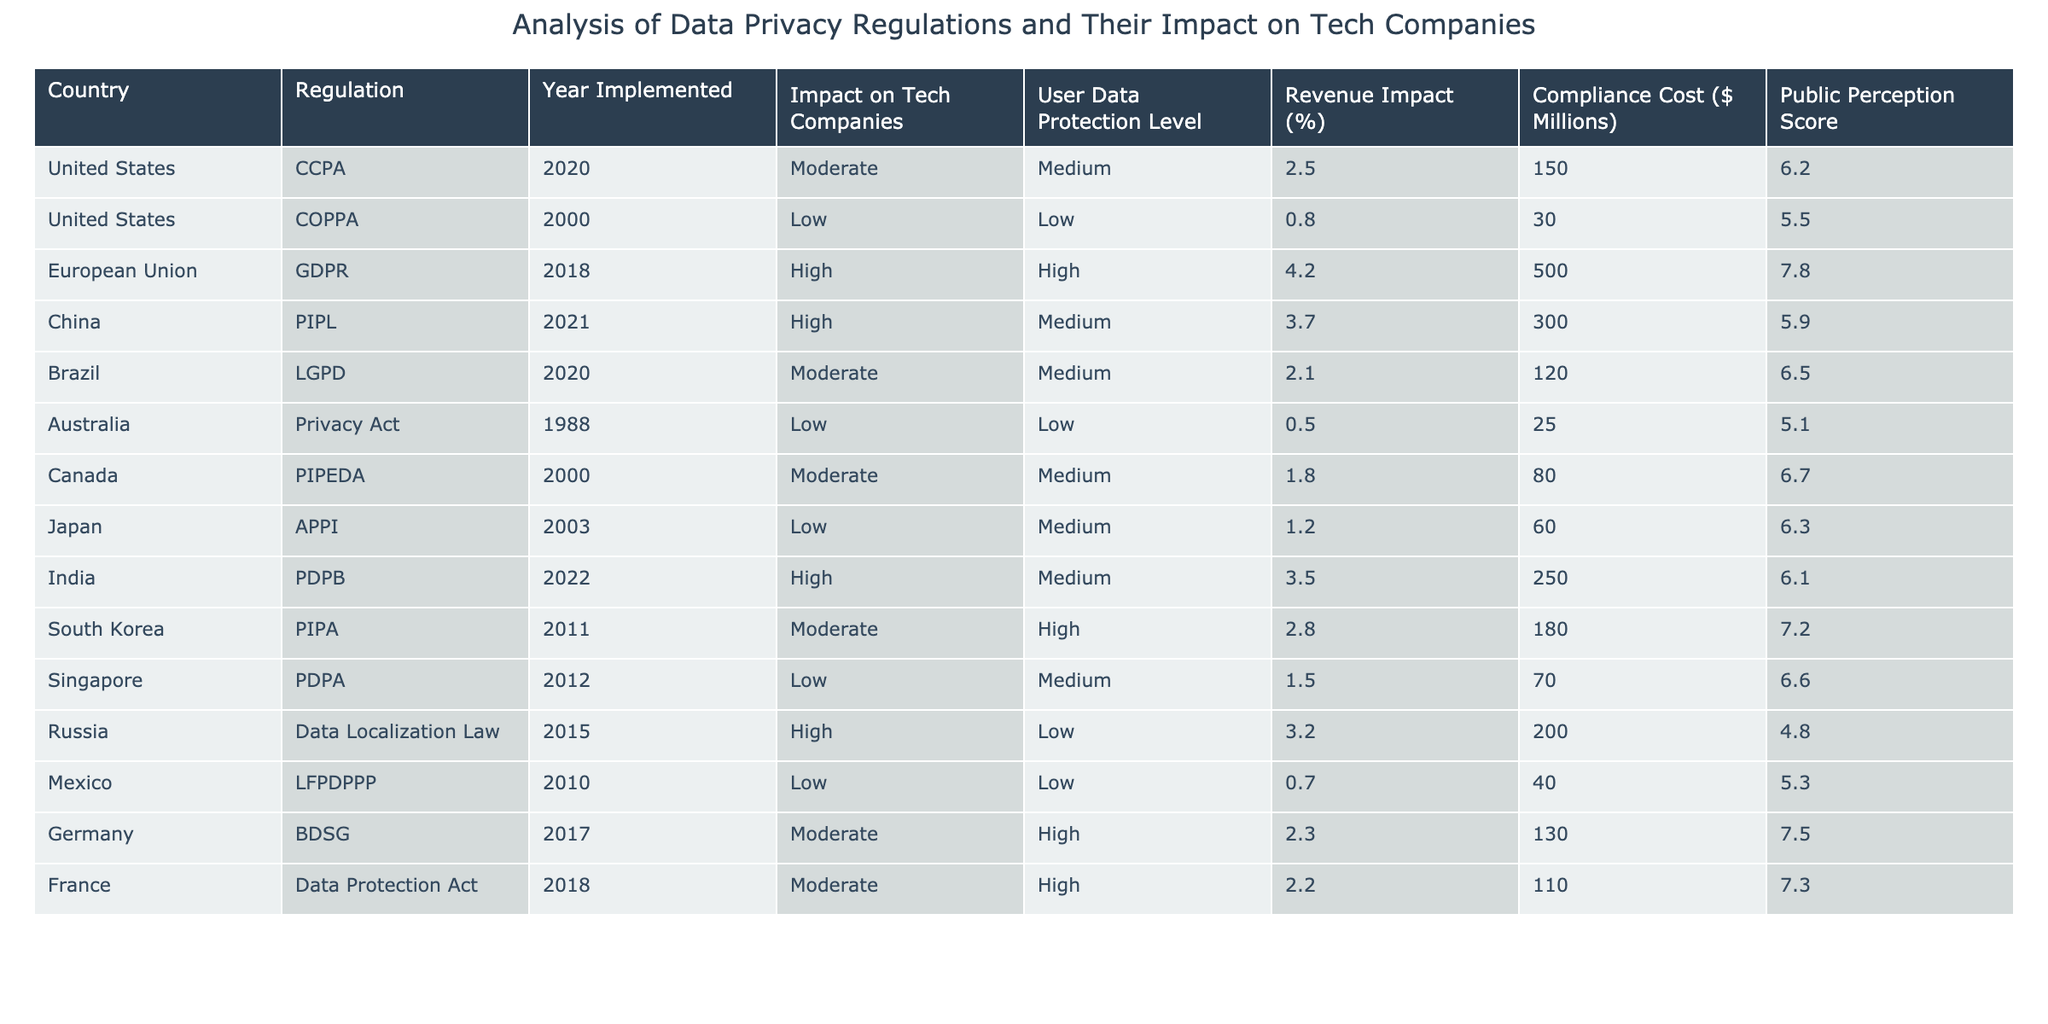What is the impact level of the GDPR on tech companies? The table lists the GDPR as having a "High" impact on tech companies.
Answer: High Which country has the highest revenue impact percentage? The table shows that the European Union (GDPR) has the highest revenue impact percentage at 4.2%.
Answer: 4.2% What is the compliance cost for the CCPA in the United States? According to the table, the compliance cost for CCPA is $150 million.
Answer: $150 million How many countries have a high user data protection level? From the table, the countries with a high user data protection level are the European Union (GDPR), China (PIPL), South Korea (PIPA), Germany (BDSG), and France (Data Protection Act), totaling five countries.
Answer: 5 What is the median compliance cost among the listed countries? First, list the compliance costs: [150, 30, 500, 300, 120, 25, 80, 60, 250, 180, 70, 200, 40, 130, 110]. The sorted costs are: [25, 30, 40, 60, 70, 80, 120, 130, 150, 180, 200, 250, 300, 500]. With 15 data points, the median is the 8th value, which is $130 million.
Answer: $130 million Which regulation has a low impact on tech companies? The table indicates COPPA, the Privacy Act, and LFPDPPP as having low impacts on tech companies.
Answer: COPPA, Privacy Act, LFPDPPP Is it true that all countries with high compliance costs also have high public perception scores? Analyzing the data, we observe that the countries with high compliance costs (GDPR, PIPL, PDPB, PIPA, Data Localization Law) do not all have high public perception scores, as Russia has a low score. Thus, the statement is false.
Answer: False What is the average user data protection level for countries with moderate impacts on tech companies? The countries with moderate impacts are the United States (CCPA, LGPD), Brazil, and Canada. Their user data protection levels are Medium, Medium, Medium, and Medium. Since they are all the same, the average remains Medium.
Answer: Medium Which country implemented data protection regulations earliest, and what was the year? Based on the table, Australia’s Privacy Act was implemented in 1988, making it the earliest data protection regulation listed.
Answer: Australia, 1988 Is there a correlation between public perception score and user data protection level? By analyzing the public perception scores and user data protection levels, we see varying scores across different protection levels, making it difficult to establish a clear correlation. Therefore, the answer is no.
Answer: No What is the total compliance cost for the top three countries with high impacts on tech companies? The costs for the top three countries with high impact (GDPR, PIPL, PDPB) are $500 million, $300 million, and $250 million, respectively. Their total is calculated: 500 + 300 + 250 = 1050 million.
Answer: $1050 million 